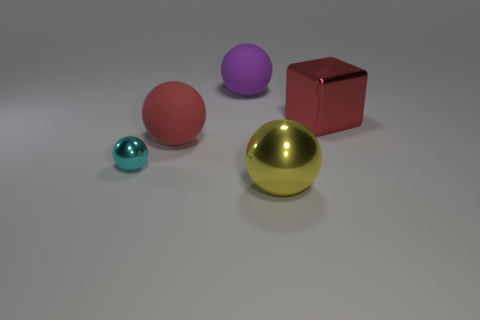Subtract 1 balls. How many balls are left? 3 Add 5 metal spheres. How many objects exist? 10 Subtract all blocks. How many objects are left? 4 Add 5 red objects. How many red objects are left? 7 Add 2 big red things. How many big red things exist? 4 Subtract 0 gray balls. How many objects are left? 5 Subtract all tiny cyan metal balls. Subtract all large metal things. How many objects are left? 2 